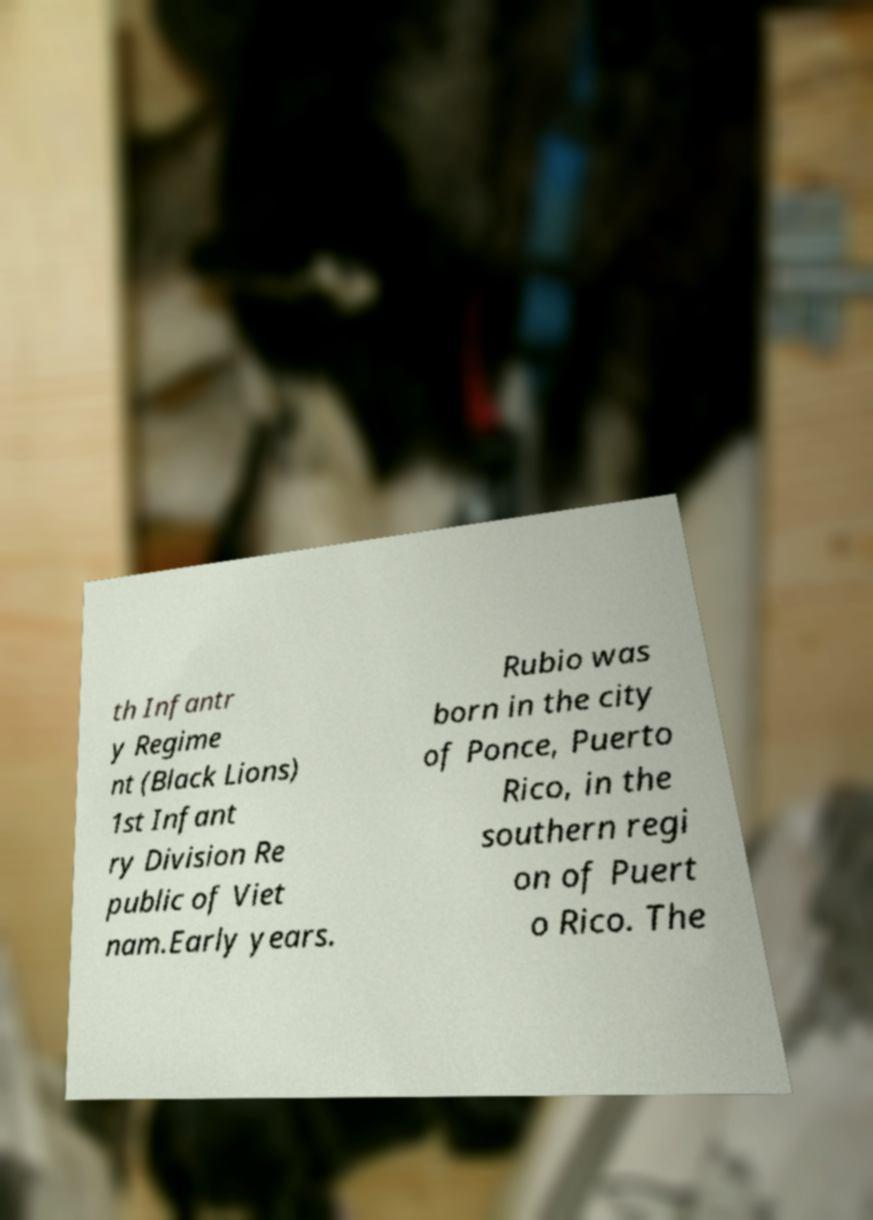Please identify and transcribe the text found in this image. th Infantr y Regime nt (Black Lions) 1st Infant ry Division Re public of Viet nam.Early years. Rubio was born in the city of Ponce, Puerto Rico, in the southern regi on of Puert o Rico. The 